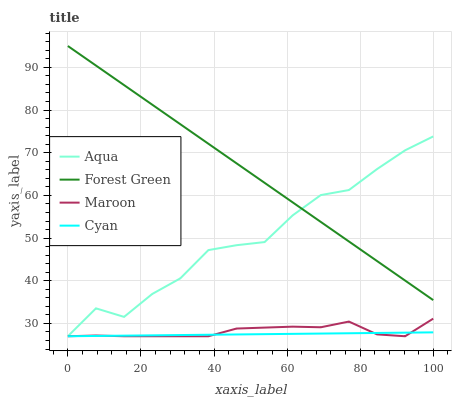Does Cyan have the minimum area under the curve?
Answer yes or no. Yes. Does Forest Green have the maximum area under the curve?
Answer yes or no. Yes. Does Aqua have the minimum area under the curve?
Answer yes or no. No. Does Aqua have the maximum area under the curve?
Answer yes or no. No. Is Cyan the smoothest?
Answer yes or no. Yes. Is Aqua the roughest?
Answer yes or no. Yes. Is Forest Green the smoothest?
Answer yes or no. No. Is Forest Green the roughest?
Answer yes or no. No. Does Forest Green have the lowest value?
Answer yes or no. No. Does Forest Green have the highest value?
Answer yes or no. Yes. Does Aqua have the highest value?
Answer yes or no. No. Is Maroon less than Forest Green?
Answer yes or no. Yes. Is Forest Green greater than Maroon?
Answer yes or no. Yes. Does Cyan intersect Maroon?
Answer yes or no. Yes. Is Cyan less than Maroon?
Answer yes or no. No. Is Cyan greater than Maroon?
Answer yes or no. No. Does Maroon intersect Forest Green?
Answer yes or no. No. 